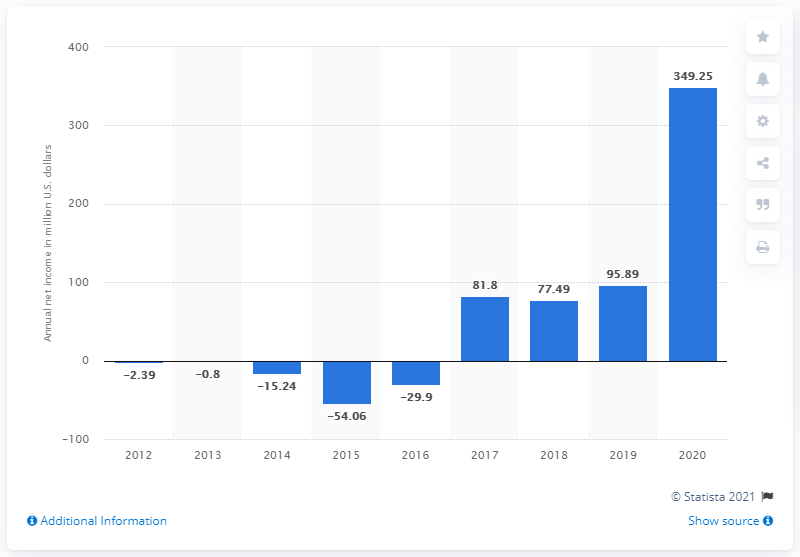Mention a couple of crucial points in this snapshot. Etsy's net income in the most recent fiscal year was $349.25 million. 